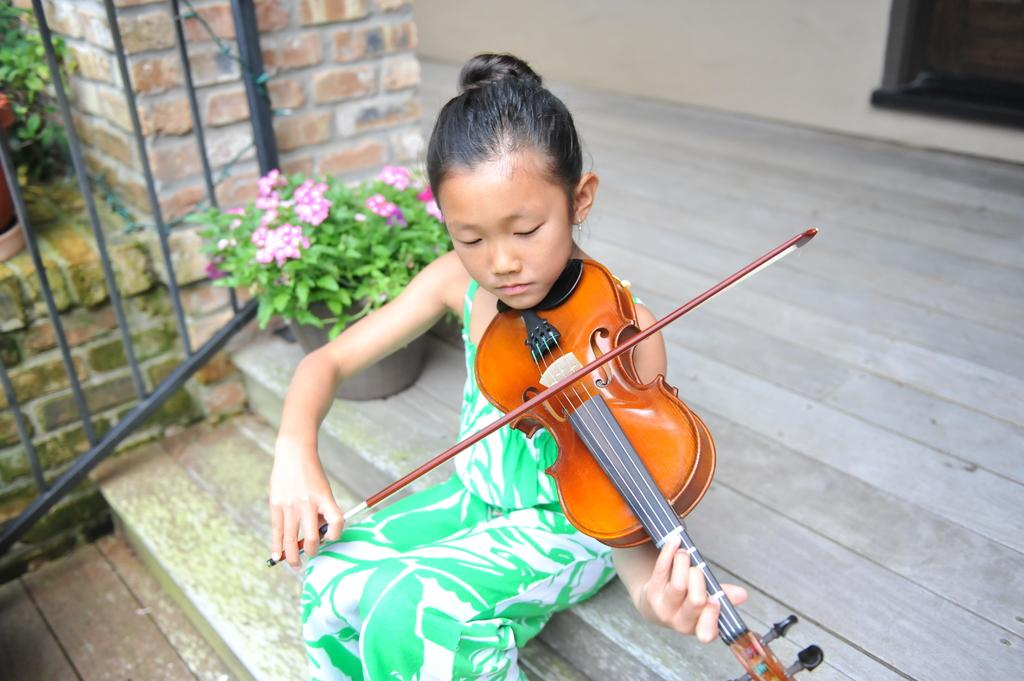What is the girl in the image doing? The girl is sitting on the floor in the image. What is the girl holding in the image? The girl is holding a violin. What can be seen in the background of the image? There is a wall, house plants, flowers, and a railing in the background of the image. What type of honey is the girl using to play the violin in the image? There is no honey present in the image, and the girl is not using any honey to play the violin. 